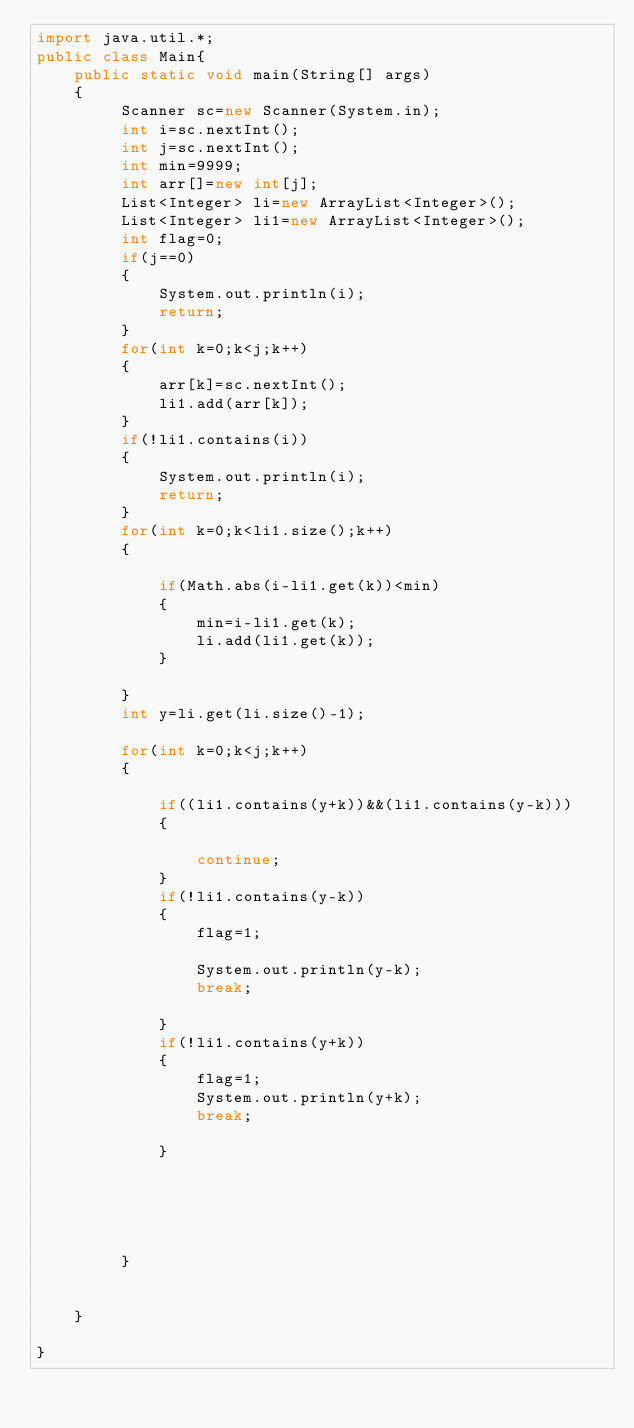<code> <loc_0><loc_0><loc_500><loc_500><_Java_>import java.util.*;
public class Main{
	public static void main(String[] args)
	{
		 Scanner sc=new Scanner(System.in);
		 int i=sc.nextInt();
		 int j=sc.nextInt();
		 int min=9999;
		 int arr[]=new int[j];
		 List<Integer> li=new ArrayList<Integer>();
		 List<Integer> li1=new ArrayList<Integer>();
		 int flag=0;
		 if(j==0)
		 {
			 System.out.println(i);
			 return;
		 }
		 for(int k=0;k<j;k++)
		 {
			 arr[k]=sc.nextInt();
			 li1.add(arr[k]);
		 }
		 if(!li1.contains(i))
		 {
			 System.out.println(i);
			 return;
		 }
		 for(int k=0;k<li1.size();k++)
		 {
			 
			 if(Math.abs(i-li1.get(k))<min)
			 {
				 min=i-li1.get(k);
				 li.add(li1.get(k));
			 }
			 
		 }
		 int y=li.get(li.size()-1);
		
		 for(int k=0;k<j;k++)
		 {
			
			 if((li1.contains(y+k))&&(li1.contains(y-k)))
			 {
				 
				 continue;
			 }
			 if(!li1.contains(y-k))
			 {
				 flag=1;
				
				 System.out.println(y-k);
                 break;
				 
			 }
			 if(!li1.contains(y+k))
			 {
				 flag=1;
				 System.out.println(y+k);
                 break;
				 
			 }
			 
			 
			 
			 
			 
		 }
		 
		 
	}

}
</code> 